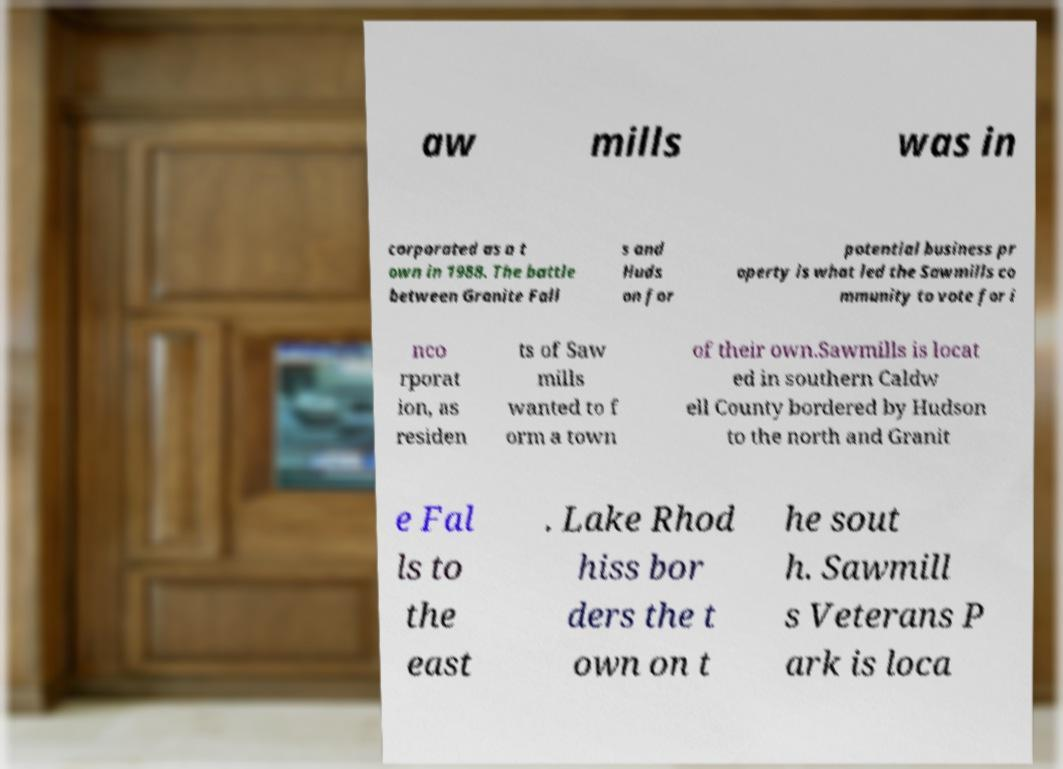There's text embedded in this image that I need extracted. Can you transcribe it verbatim? aw mills was in corporated as a t own in 1988. The battle between Granite Fall s and Huds on for potential business pr operty is what led the Sawmills co mmunity to vote for i nco rporat ion, as residen ts of Saw mills wanted to f orm a town of their own.Sawmills is locat ed in southern Caldw ell County bordered by Hudson to the north and Granit e Fal ls to the east . Lake Rhod hiss bor ders the t own on t he sout h. Sawmill s Veterans P ark is loca 